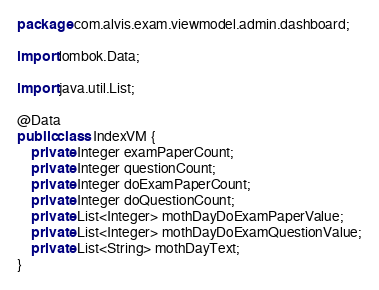Convert code to text. <code><loc_0><loc_0><loc_500><loc_500><_Java_>package com.alvis.exam.viewmodel.admin.dashboard;

import lombok.Data;

import java.util.List;

@Data
public class IndexVM {
    private Integer examPaperCount;
    private Integer questionCount;
    private Integer doExamPaperCount;
    private Integer doQuestionCount;
    private List<Integer> mothDayDoExamPaperValue;
    private List<Integer> mothDayDoExamQuestionValue;
    private List<String> mothDayText;
}
</code> 